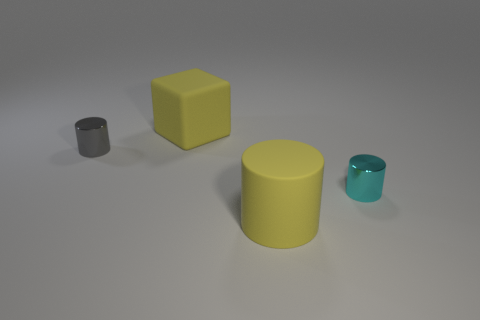Besides their shapes, what other differences can you identify between these objects? Aside from their shapes, the objects vary in color and size. The gray and the cyan objects are cylinders, while the yellow is a cube and is the largest. The textural finish of all items appears to be matte. 